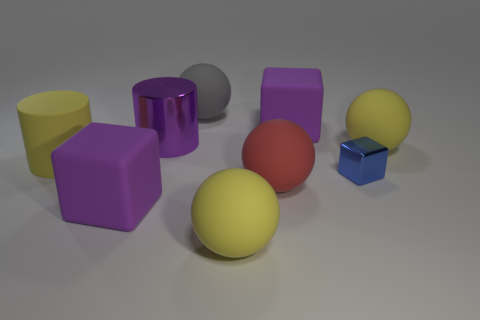Subtract all yellow balls. Subtract all yellow cubes. How many balls are left? 2 Add 1 blocks. How many objects exist? 10 Subtract all blocks. How many objects are left? 6 Add 1 large purple rubber blocks. How many large purple rubber blocks are left? 3 Add 7 large gray matte objects. How many large gray matte objects exist? 8 Subtract 1 yellow balls. How many objects are left? 8 Subtract all cubes. Subtract all small blue metallic objects. How many objects are left? 5 